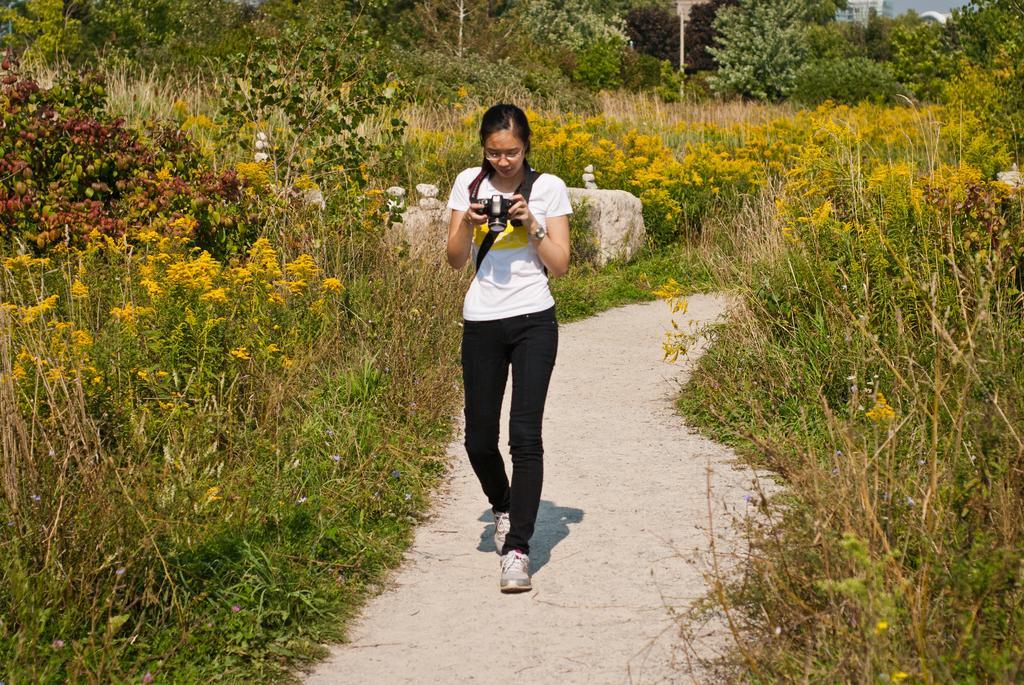Can you describe this image briefly? In this picture a girl is walking with a camera in her hands and in the background we observe small trees on the both the sides of the image. 